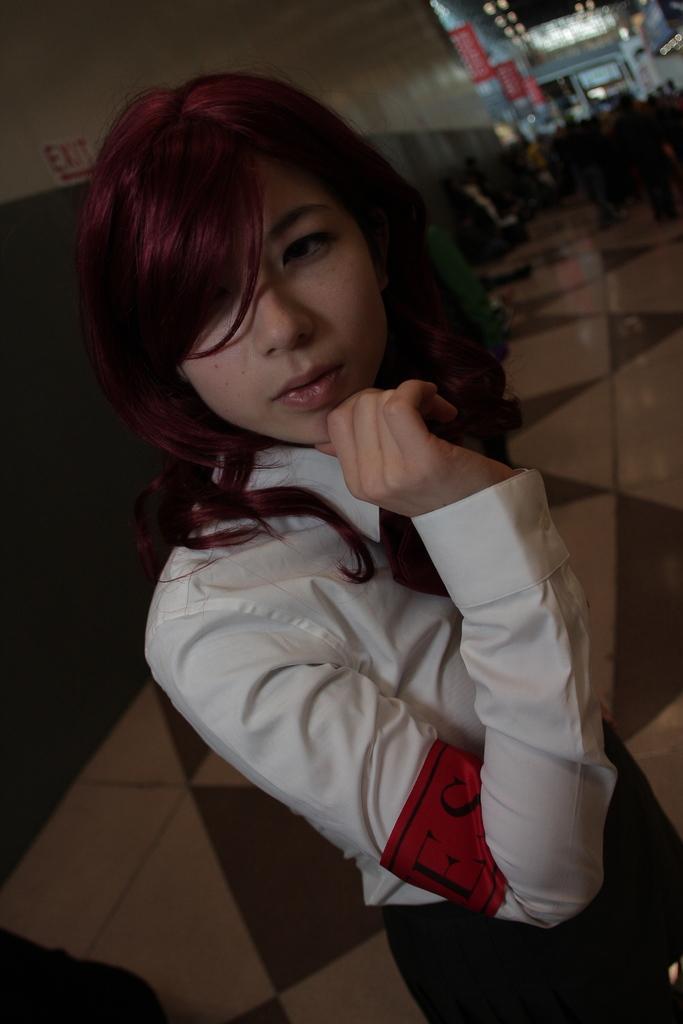In one or two sentences, can you explain what this image depicts? In this image, we can see a woman standing on the floor and we can see the wall. 